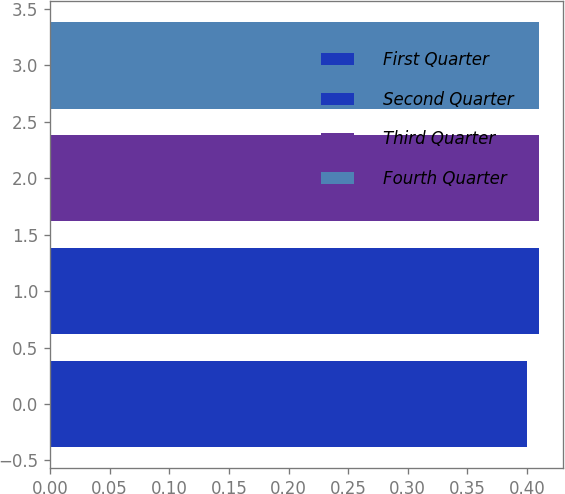Convert chart to OTSL. <chart><loc_0><loc_0><loc_500><loc_500><bar_chart><fcel>First Quarter<fcel>Second Quarter<fcel>Third Quarter<fcel>Fourth Quarter<nl><fcel>0.4<fcel>0.41<fcel>0.41<fcel>0.41<nl></chart> 